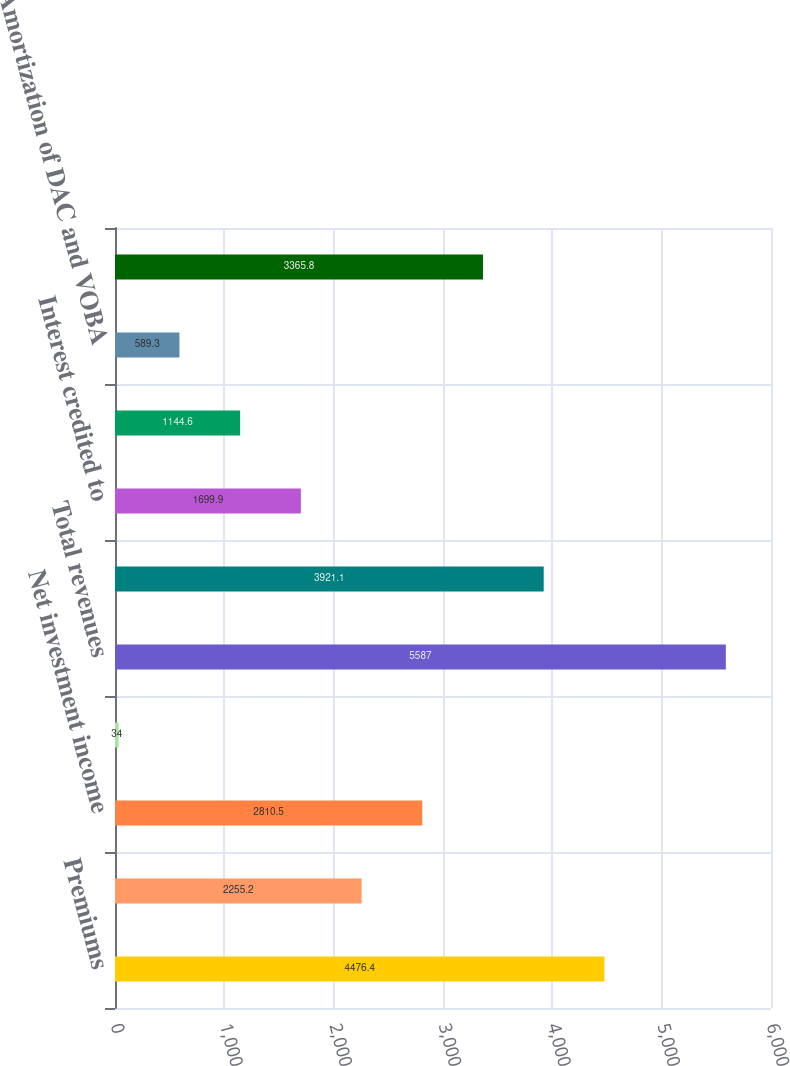<chart> <loc_0><loc_0><loc_500><loc_500><bar_chart><fcel>Premiums<fcel>Universal life and<fcel>Net investment income<fcel>Other revenues<fcel>Total revenues<fcel>Policyholder benefits and<fcel>Interest credited to<fcel>Capitalization of DAC<fcel>Amortization of DAC and VOBA<fcel>Other expenses<nl><fcel>4476.4<fcel>2255.2<fcel>2810.5<fcel>34<fcel>5587<fcel>3921.1<fcel>1699.9<fcel>1144.6<fcel>589.3<fcel>3365.8<nl></chart> 